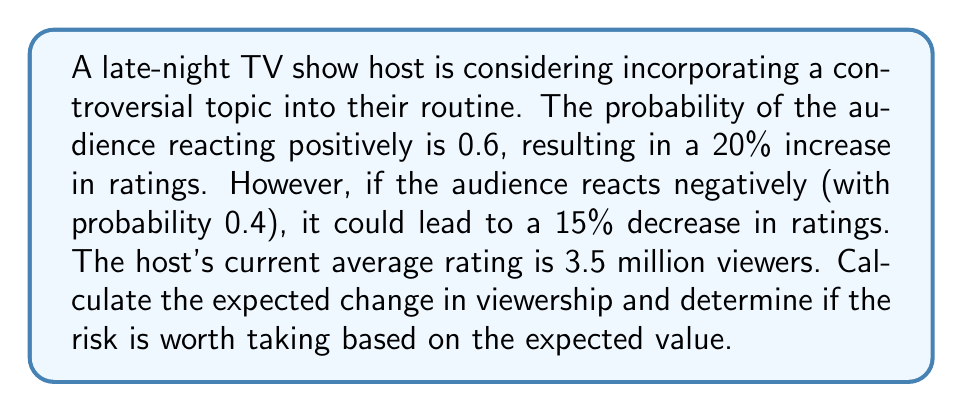Can you answer this question? To solve this problem, we need to use the concept of expected value from decision theory. Let's break it down step-by-step:

1. Define the variables:
   $p$ = probability of positive reaction = 0.6
   $q$ = probability of negative reaction = 0.4
   $C$ = current average rating = 3.5 million viewers

2. Calculate the potential outcomes:
   Positive outcome: $3.5 \times 1.20 = 4.2$ million viewers (20% increase)
   Negative outcome: $3.5 \times 0.85 = 2.975$ million viewers (15% decrease)

3. Calculate the change in viewership for each outcome:
   Positive change: $4.2 - 3.5 = 0.7$ million viewers
   Negative change: $2.975 - 3.5 = -0.525$ million viewers

4. Calculate the expected value of the change in viewership:
   $$E(\text{change}) = p \times (\text{positive change}) + q \times (\text{negative change})$$
   $$E(\text{change}) = 0.6 \times 0.7 + 0.4 \times (-0.525)$$
   $$E(\text{change}) = 0.42 - 0.21 = 0.21$$ million viewers

5. Interpret the result:
   The expected change in viewership is positive, with an increase of 0.21 million viewers. This suggests that, on average, incorporating the controversial topic is expected to increase viewership.

6. Risk assessment:
   While the expected value is positive, there is still a 40% chance of losing viewers. The potential gain (0.7 million) is larger than the potential loss (0.525 million), which supports taking the risk.
Answer: The expected change in viewership is an increase of 0.21 million viewers. Based on the positive expected value, the risk is worth taking from a purely mathematical standpoint. However, the final decision should also consider non-quantifiable factors such as the host's reputation and long-term career implications. 